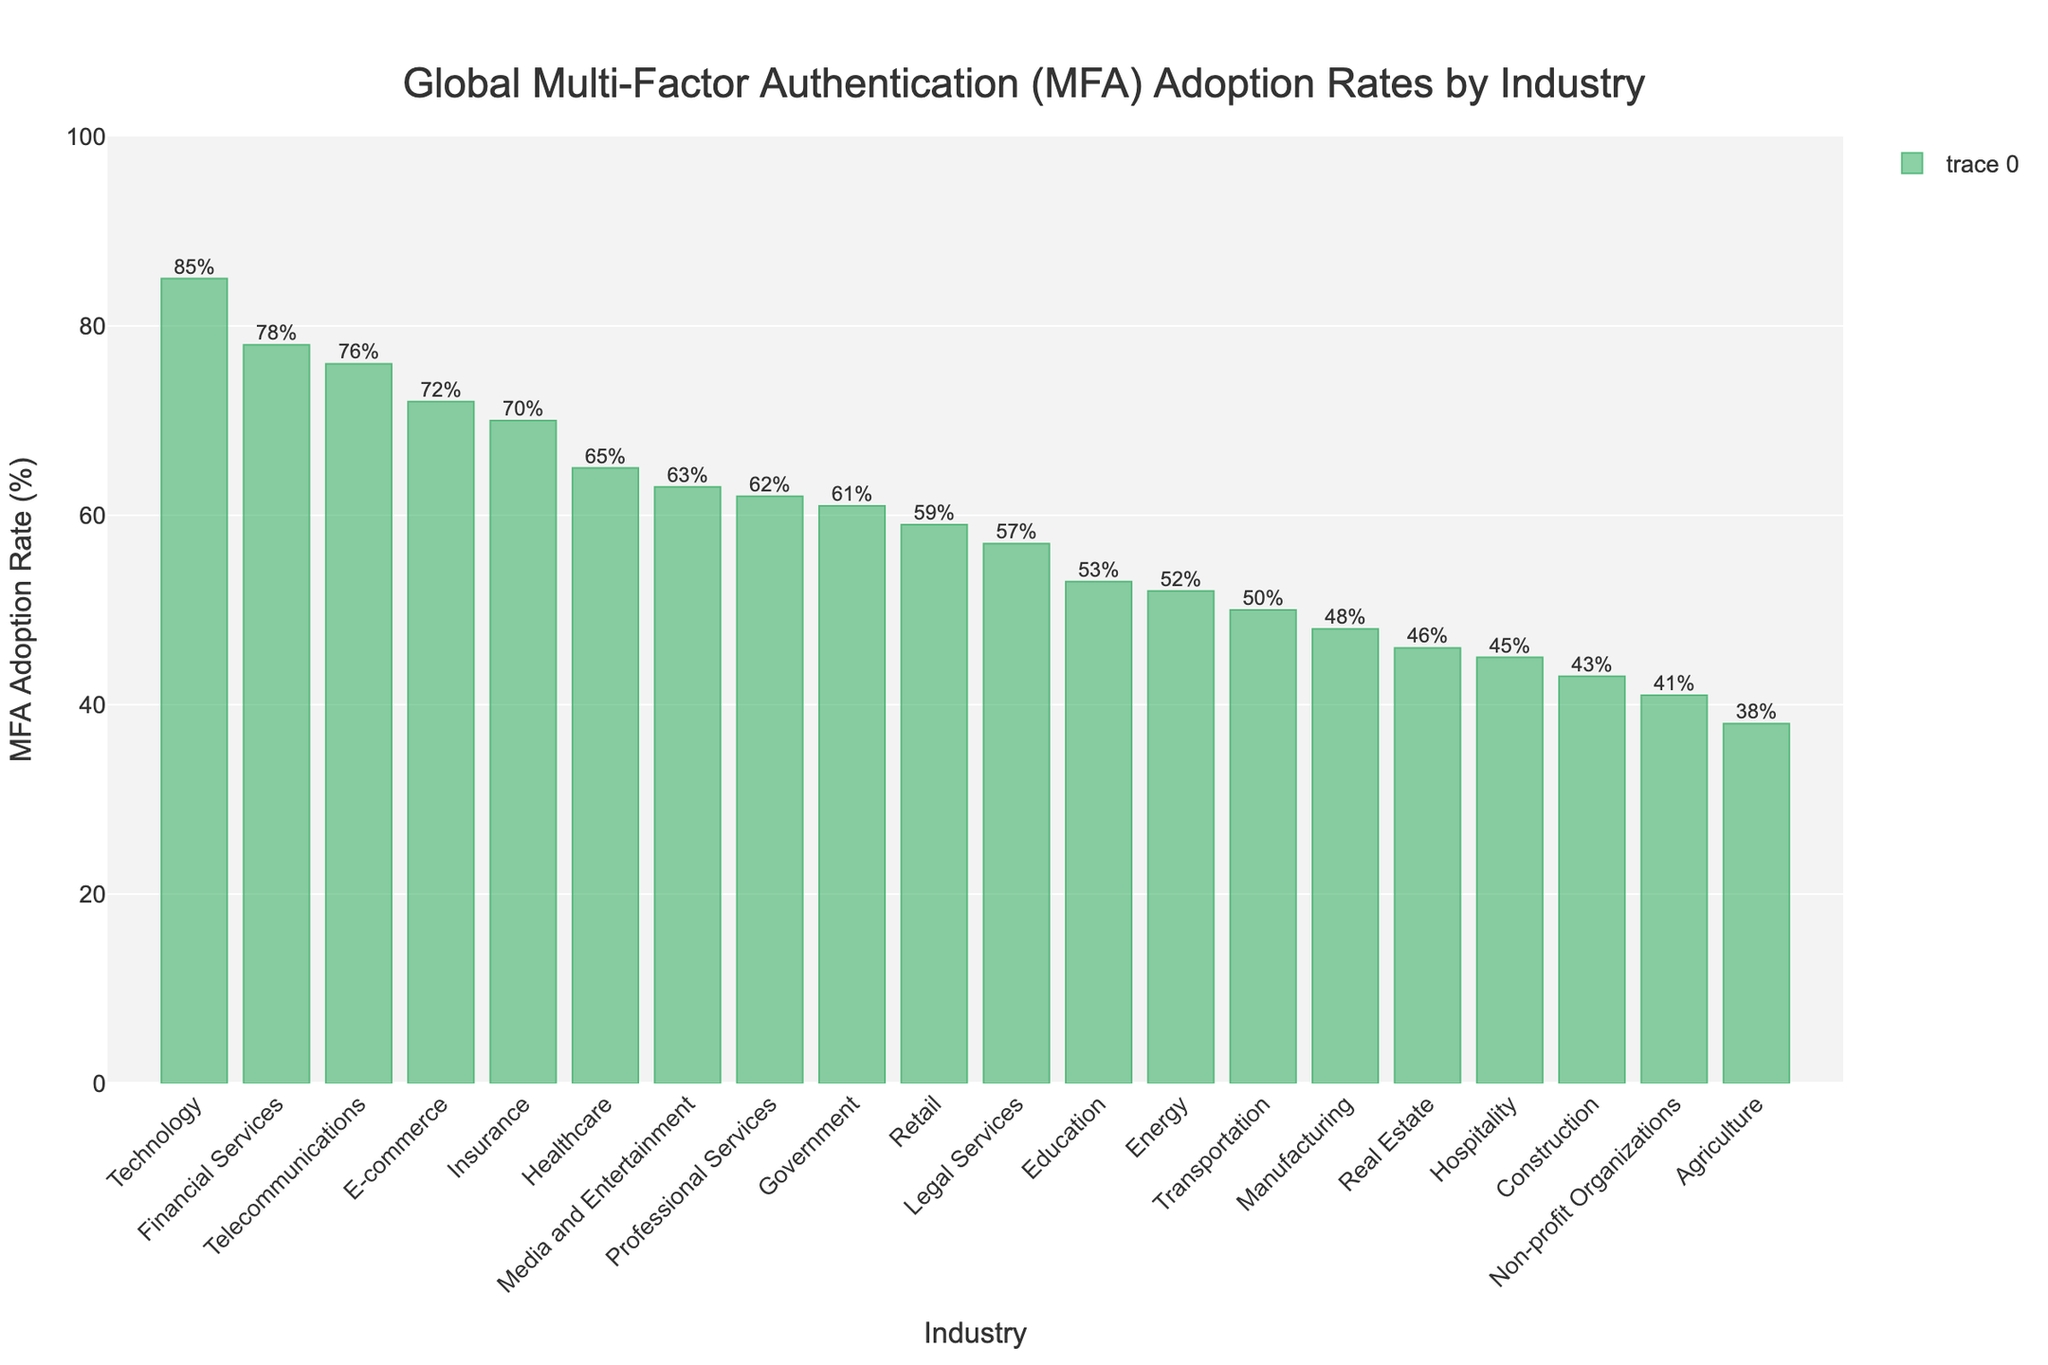Which industry has the highest MFA adoption rate? The highest bar represents the Technology industry, and it reaches up to 85%.
Answer: Technology What is the MFA adoption rate for the Healthcare industry? The bar for the Healthcare industry reaches up to 65%, as indicated by the label on top of it.
Answer: 65% Compare the MFA adoption rates of the Insurance and Legal Services industries. Which one is higher and by how much? The bar for the Insurance industry reaches up to 70%, and the bar for Legal Services reaches up to 57%. The difference is 70 - 57 = 13%.
Answer: Insurance by 13% What's the average MFA adoption rate across the Financial Services, Government, and E-commerce industries? The adoption rates for these industries are Financial Services (78%), Government (61%), and E-commerce (72%). The average is (78 + 61 + 72) / 3 = 211 / 3 = 70.33%.
Answer: 70.33% Is the MFA adoption rate for the Telecommunications industry higher than that for the Retail industry? The bar for Telecommunications industry reaches up to 76%, while the bar for Retail reaches up to 59%. Since 76% is greater than 59%, Telecommunications has a higher rate.
Answer: Yes What is the difference in MFA adoption rates between the highest and lowest industries? The highest adoption rate is in Technology (85%), and the lowest is in Agriculture (38%). The difference is 85 - 38 = 47%.
Answer: 47% Which industries have an MFA adoption rate below 50%? By observing the bars that do not reach halfway up to the 100% mark, we find Manufacturing (48%), Transportation (50%), Hospitality (45%), Non-profit Organizations (41%), Real Estate (46%), Agriculture (38%), and Construction (43%).
Answer: Manufacturing, Transportation, Hospitality, Non-profit Organizations, Real Estate, Agriculture, Construction What is the median MFA adoption rate for all the industries? First, we list all the rates in ascending order: 38, 41, 43, 45, 46, 48, 50, 52, 53, 57, 59, 61, 62, 63, 65, 70, 72, 76, 78, 85. There are 19 industries, so the median is the 10th value: 57%.
Answer: 57% Which industry has an MFA adoption rate closest to the overall average rate for all industries? The overall average rate = (sum of all rates) / 19 = (1138) / 19 ≈ 59.89%. Retail at 59% and Legal Services at 57% are the closest, with Retail being slightly closer.
Answer: Retail 